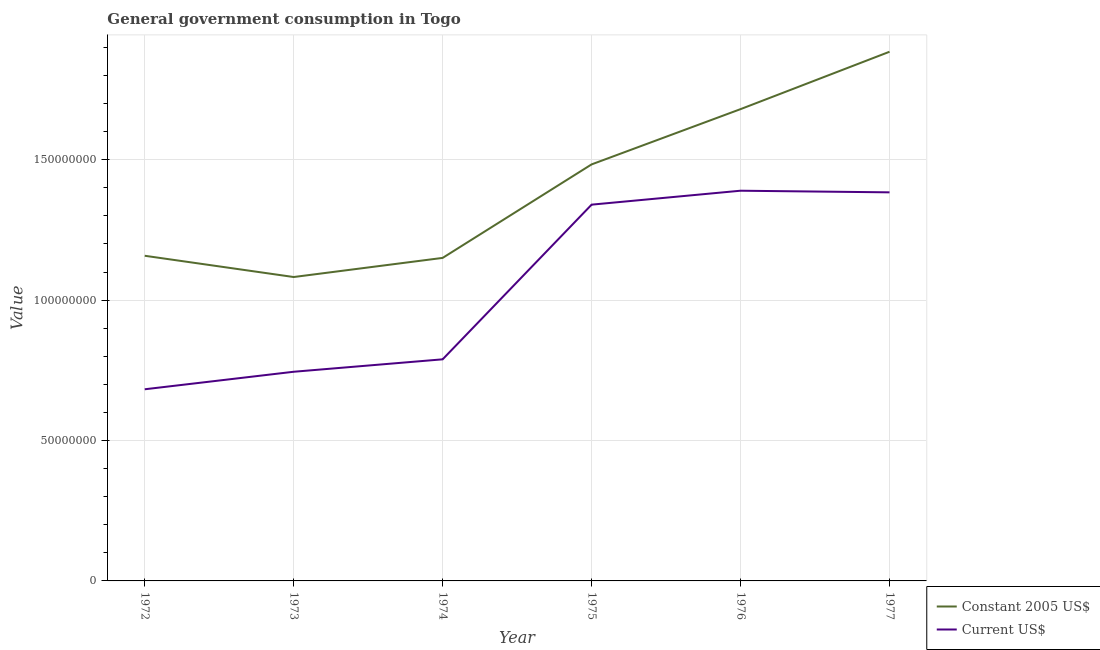What is the value consumed in current us$ in 1974?
Offer a terse response. 7.89e+07. Across all years, what is the maximum value consumed in constant 2005 us$?
Ensure brevity in your answer.  1.88e+08. Across all years, what is the minimum value consumed in current us$?
Keep it short and to the point. 6.83e+07. In which year was the value consumed in constant 2005 us$ maximum?
Keep it short and to the point. 1977. What is the total value consumed in current us$ in the graph?
Your answer should be very brief. 6.33e+08. What is the difference between the value consumed in current us$ in 1974 and that in 1977?
Offer a terse response. -5.95e+07. What is the difference between the value consumed in current us$ in 1974 and the value consumed in constant 2005 us$ in 1975?
Your response must be concise. -6.94e+07. What is the average value consumed in constant 2005 us$ per year?
Your answer should be very brief. 1.41e+08. In the year 1974, what is the difference between the value consumed in current us$ and value consumed in constant 2005 us$?
Ensure brevity in your answer.  -3.61e+07. In how many years, is the value consumed in constant 2005 us$ greater than 60000000?
Keep it short and to the point. 6. What is the ratio of the value consumed in current us$ in 1972 to that in 1977?
Offer a terse response. 0.49. Is the value consumed in constant 2005 us$ in 1976 less than that in 1977?
Keep it short and to the point. Yes. Is the difference between the value consumed in current us$ in 1975 and 1977 greater than the difference between the value consumed in constant 2005 us$ in 1975 and 1977?
Provide a short and direct response. Yes. What is the difference between the highest and the second highest value consumed in current us$?
Your answer should be very brief. 5.79e+05. What is the difference between the highest and the lowest value consumed in current us$?
Your answer should be very brief. 7.07e+07. How many lines are there?
Give a very brief answer. 2. Are the values on the major ticks of Y-axis written in scientific E-notation?
Your answer should be very brief. No. Where does the legend appear in the graph?
Your response must be concise. Bottom right. What is the title of the graph?
Make the answer very short. General government consumption in Togo. Does "Technicians" appear as one of the legend labels in the graph?
Give a very brief answer. No. What is the label or title of the X-axis?
Your answer should be very brief. Year. What is the label or title of the Y-axis?
Offer a terse response. Value. What is the Value of Constant 2005 US$ in 1972?
Make the answer very short. 1.16e+08. What is the Value of Current US$ in 1972?
Your answer should be compact. 6.83e+07. What is the Value in Constant 2005 US$ in 1973?
Your response must be concise. 1.08e+08. What is the Value in Current US$ in 1973?
Your answer should be very brief. 7.45e+07. What is the Value in Constant 2005 US$ in 1974?
Your answer should be very brief. 1.15e+08. What is the Value in Current US$ in 1974?
Keep it short and to the point. 7.89e+07. What is the Value of Constant 2005 US$ in 1975?
Make the answer very short. 1.48e+08. What is the Value in Current US$ in 1975?
Provide a succinct answer. 1.34e+08. What is the Value in Constant 2005 US$ in 1976?
Make the answer very short. 1.68e+08. What is the Value in Current US$ in 1976?
Your answer should be very brief. 1.39e+08. What is the Value in Constant 2005 US$ in 1977?
Provide a short and direct response. 1.88e+08. What is the Value of Current US$ in 1977?
Offer a very short reply. 1.38e+08. Across all years, what is the maximum Value of Constant 2005 US$?
Give a very brief answer. 1.88e+08. Across all years, what is the maximum Value in Current US$?
Provide a short and direct response. 1.39e+08. Across all years, what is the minimum Value in Constant 2005 US$?
Keep it short and to the point. 1.08e+08. Across all years, what is the minimum Value in Current US$?
Provide a short and direct response. 6.83e+07. What is the total Value in Constant 2005 US$ in the graph?
Your answer should be compact. 8.44e+08. What is the total Value of Current US$ in the graph?
Give a very brief answer. 6.33e+08. What is the difference between the Value of Constant 2005 US$ in 1972 and that in 1973?
Your answer should be very brief. 7.57e+06. What is the difference between the Value of Current US$ in 1972 and that in 1973?
Offer a terse response. -6.24e+06. What is the difference between the Value of Constant 2005 US$ in 1972 and that in 1974?
Provide a succinct answer. 7.57e+05. What is the difference between the Value of Current US$ in 1972 and that in 1974?
Keep it short and to the point. -1.07e+07. What is the difference between the Value in Constant 2005 US$ in 1972 and that in 1975?
Your answer should be very brief. -3.25e+07. What is the difference between the Value of Current US$ in 1972 and that in 1975?
Give a very brief answer. -6.58e+07. What is the difference between the Value of Constant 2005 US$ in 1972 and that in 1976?
Provide a succinct answer. -5.22e+07. What is the difference between the Value in Current US$ in 1972 and that in 1976?
Offer a terse response. -7.07e+07. What is the difference between the Value in Constant 2005 US$ in 1972 and that in 1977?
Provide a short and direct response. -7.27e+07. What is the difference between the Value in Current US$ in 1972 and that in 1977?
Your answer should be compact. -7.01e+07. What is the difference between the Value in Constant 2005 US$ in 1973 and that in 1974?
Provide a succinct answer. -6.81e+06. What is the difference between the Value of Current US$ in 1973 and that in 1974?
Your answer should be very brief. -4.43e+06. What is the difference between the Value in Constant 2005 US$ in 1973 and that in 1975?
Ensure brevity in your answer.  -4.01e+07. What is the difference between the Value in Current US$ in 1973 and that in 1975?
Your response must be concise. -5.95e+07. What is the difference between the Value of Constant 2005 US$ in 1973 and that in 1976?
Your response must be concise. -5.98e+07. What is the difference between the Value of Current US$ in 1973 and that in 1976?
Offer a terse response. -6.45e+07. What is the difference between the Value in Constant 2005 US$ in 1973 and that in 1977?
Give a very brief answer. -8.02e+07. What is the difference between the Value in Current US$ in 1973 and that in 1977?
Make the answer very short. -6.39e+07. What is the difference between the Value of Constant 2005 US$ in 1974 and that in 1975?
Make the answer very short. -3.33e+07. What is the difference between the Value of Current US$ in 1974 and that in 1975?
Give a very brief answer. -5.51e+07. What is the difference between the Value in Constant 2005 US$ in 1974 and that in 1976?
Offer a terse response. -5.30e+07. What is the difference between the Value of Current US$ in 1974 and that in 1976?
Your answer should be very brief. -6.00e+07. What is the difference between the Value of Constant 2005 US$ in 1974 and that in 1977?
Offer a very short reply. -7.34e+07. What is the difference between the Value of Current US$ in 1974 and that in 1977?
Your response must be concise. -5.95e+07. What is the difference between the Value of Constant 2005 US$ in 1975 and that in 1976?
Make the answer very short. -1.97e+07. What is the difference between the Value in Current US$ in 1975 and that in 1976?
Provide a succinct answer. -4.96e+06. What is the difference between the Value of Constant 2005 US$ in 1975 and that in 1977?
Provide a short and direct response. -4.01e+07. What is the difference between the Value of Current US$ in 1975 and that in 1977?
Give a very brief answer. -4.38e+06. What is the difference between the Value in Constant 2005 US$ in 1976 and that in 1977?
Give a very brief answer. -2.04e+07. What is the difference between the Value of Current US$ in 1976 and that in 1977?
Give a very brief answer. 5.79e+05. What is the difference between the Value of Constant 2005 US$ in 1972 and the Value of Current US$ in 1973?
Your answer should be very brief. 4.13e+07. What is the difference between the Value of Constant 2005 US$ in 1972 and the Value of Current US$ in 1974?
Offer a terse response. 3.69e+07. What is the difference between the Value in Constant 2005 US$ in 1972 and the Value in Current US$ in 1975?
Your answer should be very brief. -1.82e+07. What is the difference between the Value of Constant 2005 US$ in 1972 and the Value of Current US$ in 1976?
Give a very brief answer. -2.32e+07. What is the difference between the Value of Constant 2005 US$ in 1972 and the Value of Current US$ in 1977?
Provide a succinct answer. -2.26e+07. What is the difference between the Value of Constant 2005 US$ in 1973 and the Value of Current US$ in 1974?
Offer a very short reply. 2.93e+07. What is the difference between the Value of Constant 2005 US$ in 1973 and the Value of Current US$ in 1975?
Ensure brevity in your answer.  -2.58e+07. What is the difference between the Value of Constant 2005 US$ in 1973 and the Value of Current US$ in 1976?
Your answer should be very brief. -3.07e+07. What is the difference between the Value in Constant 2005 US$ in 1973 and the Value in Current US$ in 1977?
Your answer should be compact. -3.02e+07. What is the difference between the Value of Constant 2005 US$ in 1974 and the Value of Current US$ in 1975?
Give a very brief answer. -1.90e+07. What is the difference between the Value of Constant 2005 US$ in 1974 and the Value of Current US$ in 1976?
Ensure brevity in your answer.  -2.39e+07. What is the difference between the Value of Constant 2005 US$ in 1974 and the Value of Current US$ in 1977?
Provide a short and direct response. -2.33e+07. What is the difference between the Value in Constant 2005 US$ in 1975 and the Value in Current US$ in 1976?
Offer a terse response. 9.38e+06. What is the difference between the Value in Constant 2005 US$ in 1975 and the Value in Current US$ in 1977?
Offer a very short reply. 9.96e+06. What is the difference between the Value in Constant 2005 US$ in 1976 and the Value in Current US$ in 1977?
Provide a succinct answer. 2.96e+07. What is the average Value of Constant 2005 US$ per year?
Provide a short and direct response. 1.41e+08. What is the average Value in Current US$ per year?
Your response must be concise. 1.06e+08. In the year 1972, what is the difference between the Value in Constant 2005 US$ and Value in Current US$?
Your response must be concise. 4.75e+07. In the year 1973, what is the difference between the Value of Constant 2005 US$ and Value of Current US$?
Make the answer very short. 3.37e+07. In the year 1974, what is the difference between the Value of Constant 2005 US$ and Value of Current US$?
Offer a very short reply. 3.61e+07. In the year 1975, what is the difference between the Value of Constant 2005 US$ and Value of Current US$?
Your answer should be compact. 1.43e+07. In the year 1976, what is the difference between the Value in Constant 2005 US$ and Value in Current US$?
Keep it short and to the point. 2.91e+07. In the year 1977, what is the difference between the Value of Constant 2005 US$ and Value of Current US$?
Make the answer very short. 5.01e+07. What is the ratio of the Value of Constant 2005 US$ in 1972 to that in 1973?
Ensure brevity in your answer.  1.07. What is the ratio of the Value of Current US$ in 1972 to that in 1973?
Give a very brief answer. 0.92. What is the ratio of the Value of Constant 2005 US$ in 1972 to that in 1974?
Give a very brief answer. 1.01. What is the ratio of the Value in Current US$ in 1972 to that in 1974?
Give a very brief answer. 0.86. What is the ratio of the Value of Constant 2005 US$ in 1972 to that in 1975?
Your response must be concise. 0.78. What is the ratio of the Value of Current US$ in 1972 to that in 1975?
Keep it short and to the point. 0.51. What is the ratio of the Value of Constant 2005 US$ in 1972 to that in 1976?
Make the answer very short. 0.69. What is the ratio of the Value of Current US$ in 1972 to that in 1976?
Provide a short and direct response. 0.49. What is the ratio of the Value in Constant 2005 US$ in 1972 to that in 1977?
Give a very brief answer. 0.61. What is the ratio of the Value in Current US$ in 1972 to that in 1977?
Offer a terse response. 0.49. What is the ratio of the Value of Constant 2005 US$ in 1973 to that in 1974?
Ensure brevity in your answer.  0.94. What is the ratio of the Value of Current US$ in 1973 to that in 1974?
Offer a very short reply. 0.94. What is the ratio of the Value in Constant 2005 US$ in 1973 to that in 1975?
Offer a terse response. 0.73. What is the ratio of the Value in Current US$ in 1973 to that in 1975?
Keep it short and to the point. 0.56. What is the ratio of the Value in Constant 2005 US$ in 1973 to that in 1976?
Make the answer very short. 0.64. What is the ratio of the Value of Current US$ in 1973 to that in 1976?
Keep it short and to the point. 0.54. What is the ratio of the Value in Constant 2005 US$ in 1973 to that in 1977?
Make the answer very short. 0.57. What is the ratio of the Value of Current US$ in 1973 to that in 1977?
Ensure brevity in your answer.  0.54. What is the ratio of the Value of Constant 2005 US$ in 1974 to that in 1975?
Give a very brief answer. 0.78. What is the ratio of the Value of Current US$ in 1974 to that in 1975?
Offer a very short reply. 0.59. What is the ratio of the Value of Constant 2005 US$ in 1974 to that in 1976?
Make the answer very short. 0.68. What is the ratio of the Value in Current US$ in 1974 to that in 1976?
Ensure brevity in your answer.  0.57. What is the ratio of the Value in Constant 2005 US$ in 1974 to that in 1977?
Offer a terse response. 0.61. What is the ratio of the Value in Current US$ in 1974 to that in 1977?
Your answer should be very brief. 0.57. What is the ratio of the Value of Constant 2005 US$ in 1975 to that in 1976?
Your answer should be compact. 0.88. What is the ratio of the Value of Constant 2005 US$ in 1975 to that in 1977?
Keep it short and to the point. 0.79. What is the ratio of the Value in Current US$ in 1975 to that in 1977?
Offer a very short reply. 0.97. What is the ratio of the Value in Constant 2005 US$ in 1976 to that in 1977?
Provide a succinct answer. 0.89. What is the difference between the highest and the second highest Value in Constant 2005 US$?
Provide a succinct answer. 2.04e+07. What is the difference between the highest and the second highest Value of Current US$?
Provide a succinct answer. 5.79e+05. What is the difference between the highest and the lowest Value of Constant 2005 US$?
Ensure brevity in your answer.  8.02e+07. What is the difference between the highest and the lowest Value of Current US$?
Your answer should be compact. 7.07e+07. 